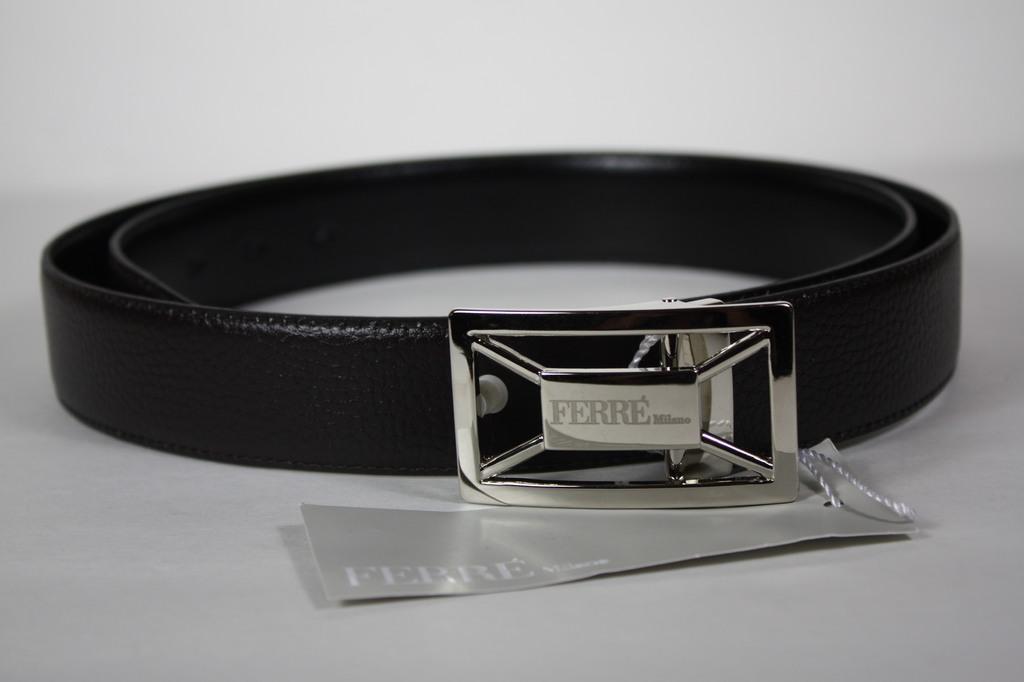Describe this image in one or two sentences. In this image there is a belt and there is a metal object with some text written on it. 